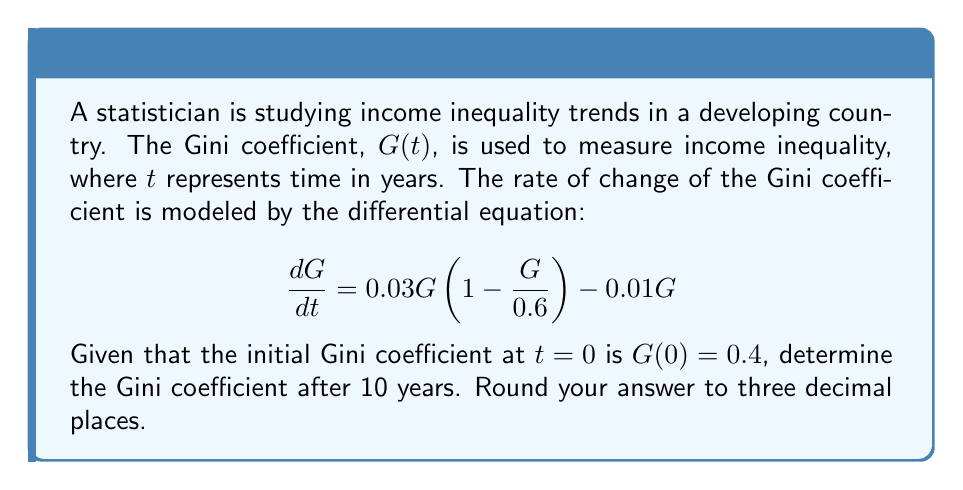Could you help me with this problem? To solve this problem, we need to follow these steps:

1) First, we recognize that this is a logistic differential equation with an additional linear term. We can rewrite it as:

   $$\frac{dG}{dt} = 0.03G - 0.05G^2 - 0.01G = 0.02G - 0.05G^2$$

2) This equation is in the form of a Bernoulli differential equation:

   $$\frac{dG}{dt} + P(t)G = Q(t)G^n$$

   where $P(t) = -0.02$, $Q(t) = 0.05$, and $n = 2$

3) To solve this, we use the substitution $v = G^{1-n} = G^{-1}$. This gives us:

   $$\frac{dv}{dt} = (1-n)G^{-n}\frac{dG}{dt} = -G^{-2}\frac{dG}{dt}$$

4) Substituting this into our original equation:

   $$-G^2\frac{dv}{dt} = 0.02G - 0.05G^2$$

   $$\frac{dv}{dt} = -0.02v + 0.05$$

5) This is now a linear first-order ODE. We can solve it using an integrating factor:

   $$\mu(t) = e^{\int 0.02 dt} = e^{0.02t}$$

6) Multiplying both sides by $\mu(t)$:

   $$e^{0.02t}\frac{dv}{dt} + 0.02e^{0.02t}v = 0.05e^{0.02t}$$

7) This can be written as:

   $$\frac{d}{dt}(e^{0.02t}v) = 0.05e^{0.02t}$$

8) Integrating both sides:

   $$e^{0.02t}v = 2.5e^{0.02t} + C$$

9) Solving for $v$:

   $$v = 2.5 + Ce^{-0.02t}$$

10) Remember that $v = G^{-1}$, so:

    $$G = \frac{1}{2.5 + Ce^{-0.02t}}$$

11) Using the initial condition $G(0) = 0.4$:

    $$0.4 = \frac{1}{2.5 + C}$$
    $$C = 0$$

12) Therefore, our solution is:

    $$G(t) = \frac{1}{2.5} = 0.4$$

13) After 10 years, $t = 10$, but since our solution is constant, the Gini coefficient remains 0.4.
Answer: 0.400 